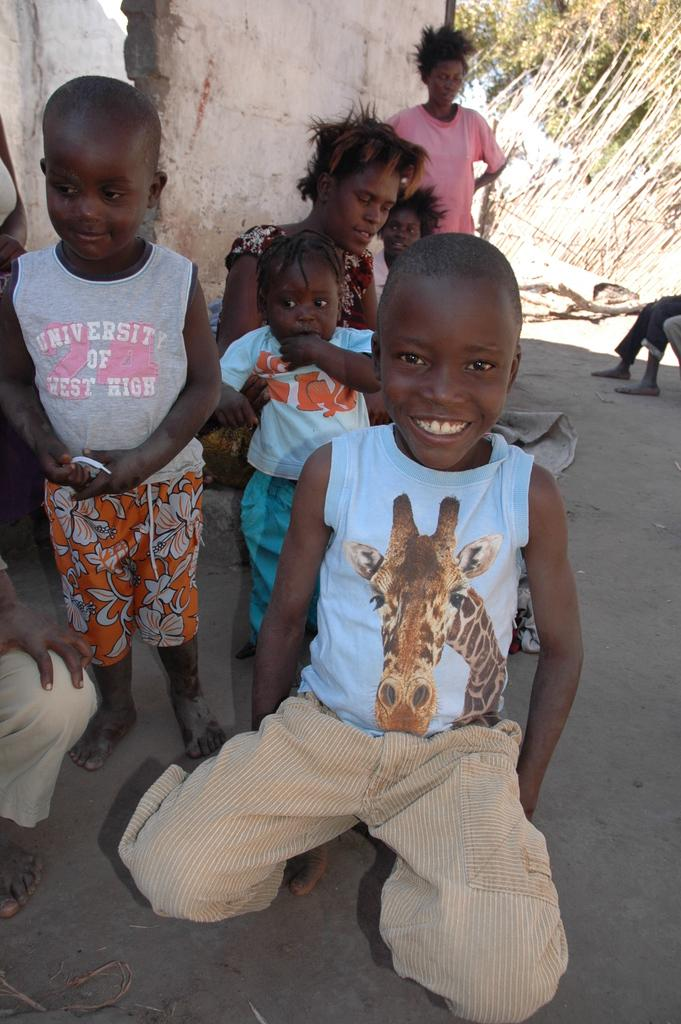What is the main subject of the image? The main subject of the image is little kids. How are the kids in the image? The kids are smiling. What can be seen in the background of the image? There is a wall, trees, people, and other objects in the background of the image. What is the source of wealth depicted in the image? There is no source of wealth depicted in the image; it features little kids smiling in the center and various elements in the background. How many geese are present in the image? There are no geese present in the image. 